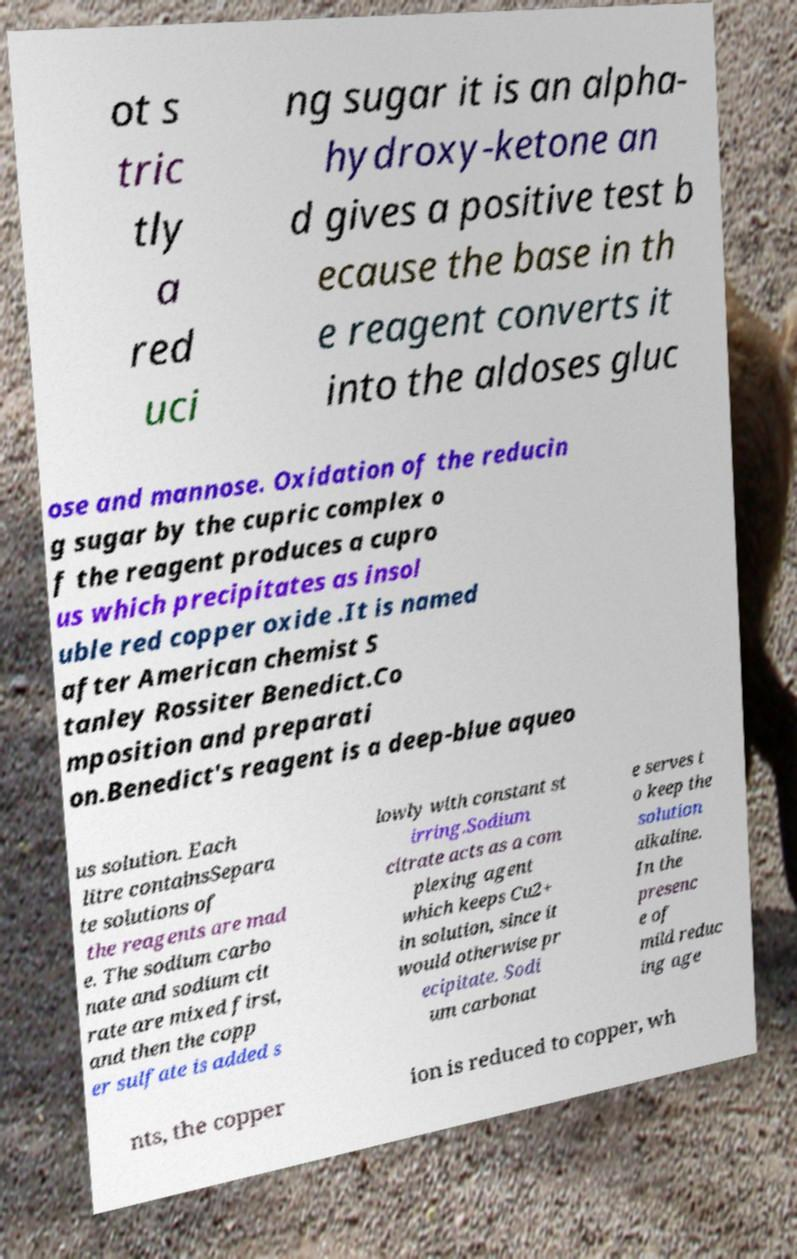For documentation purposes, I need the text within this image transcribed. Could you provide that? ot s tric tly a red uci ng sugar it is an alpha- hydroxy-ketone an d gives a positive test b ecause the base in th e reagent converts it into the aldoses gluc ose and mannose. Oxidation of the reducin g sugar by the cupric complex o f the reagent produces a cupro us which precipitates as insol uble red copper oxide .It is named after American chemist S tanley Rossiter Benedict.Co mposition and preparati on.Benedict's reagent is a deep-blue aqueo us solution. Each litre containsSepara te solutions of the reagents are mad e. The sodium carbo nate and sodium cit rate are mixed first, and then the copp er sulfate is added s lowly with constant st irring.Sodium citrate acts as a com plexing agent which keeps Cu2+ in solution, since it would otherwise pr ecipitate. Sodi um carbonat e serves t o keep the solution alkaline. In the presenc e of mild reduc ing age nts, the copper ion is reduced to copper, wh 